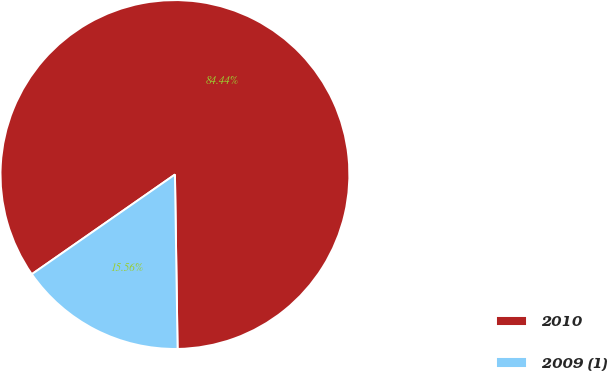Convert chart. <chart><loc_0><loc_0><loc_500><loc_500><pie_chart><fcel>2010<fcel>2009 (1)<nl><fcel>84.44%<fcel>15.56%<nl></chart> 